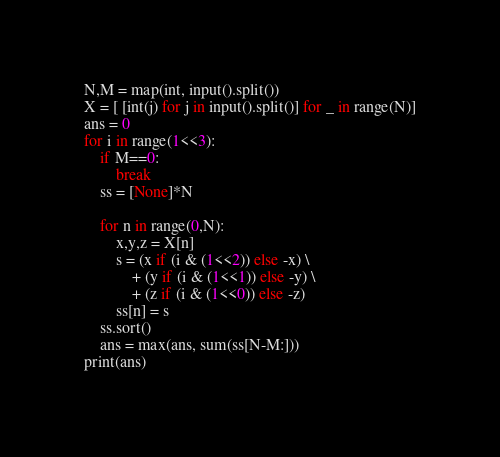<code> <loc_0><loc_0><loc_500><loc_500><_Python_>N,M = map(int, input().split())
X = [ [int(j) for j in input().split()] for _ in range(N)]
ans = 0
for i in range(1<<3):
    if M==0:
        break
    ss = [None]*N

    for n in range(0,N):
        x,y,z = X[n]
        s = (x if (i & (1<<2)) else -x) \
            + (y if (i & (1<<1)) else -y) \
            + (z if (i & (1<<0)) else -z)
        ss[n] = s
    ss.sort()
    ans = max(ans, sum(ss[N-M:]))
print(ans)</code> 